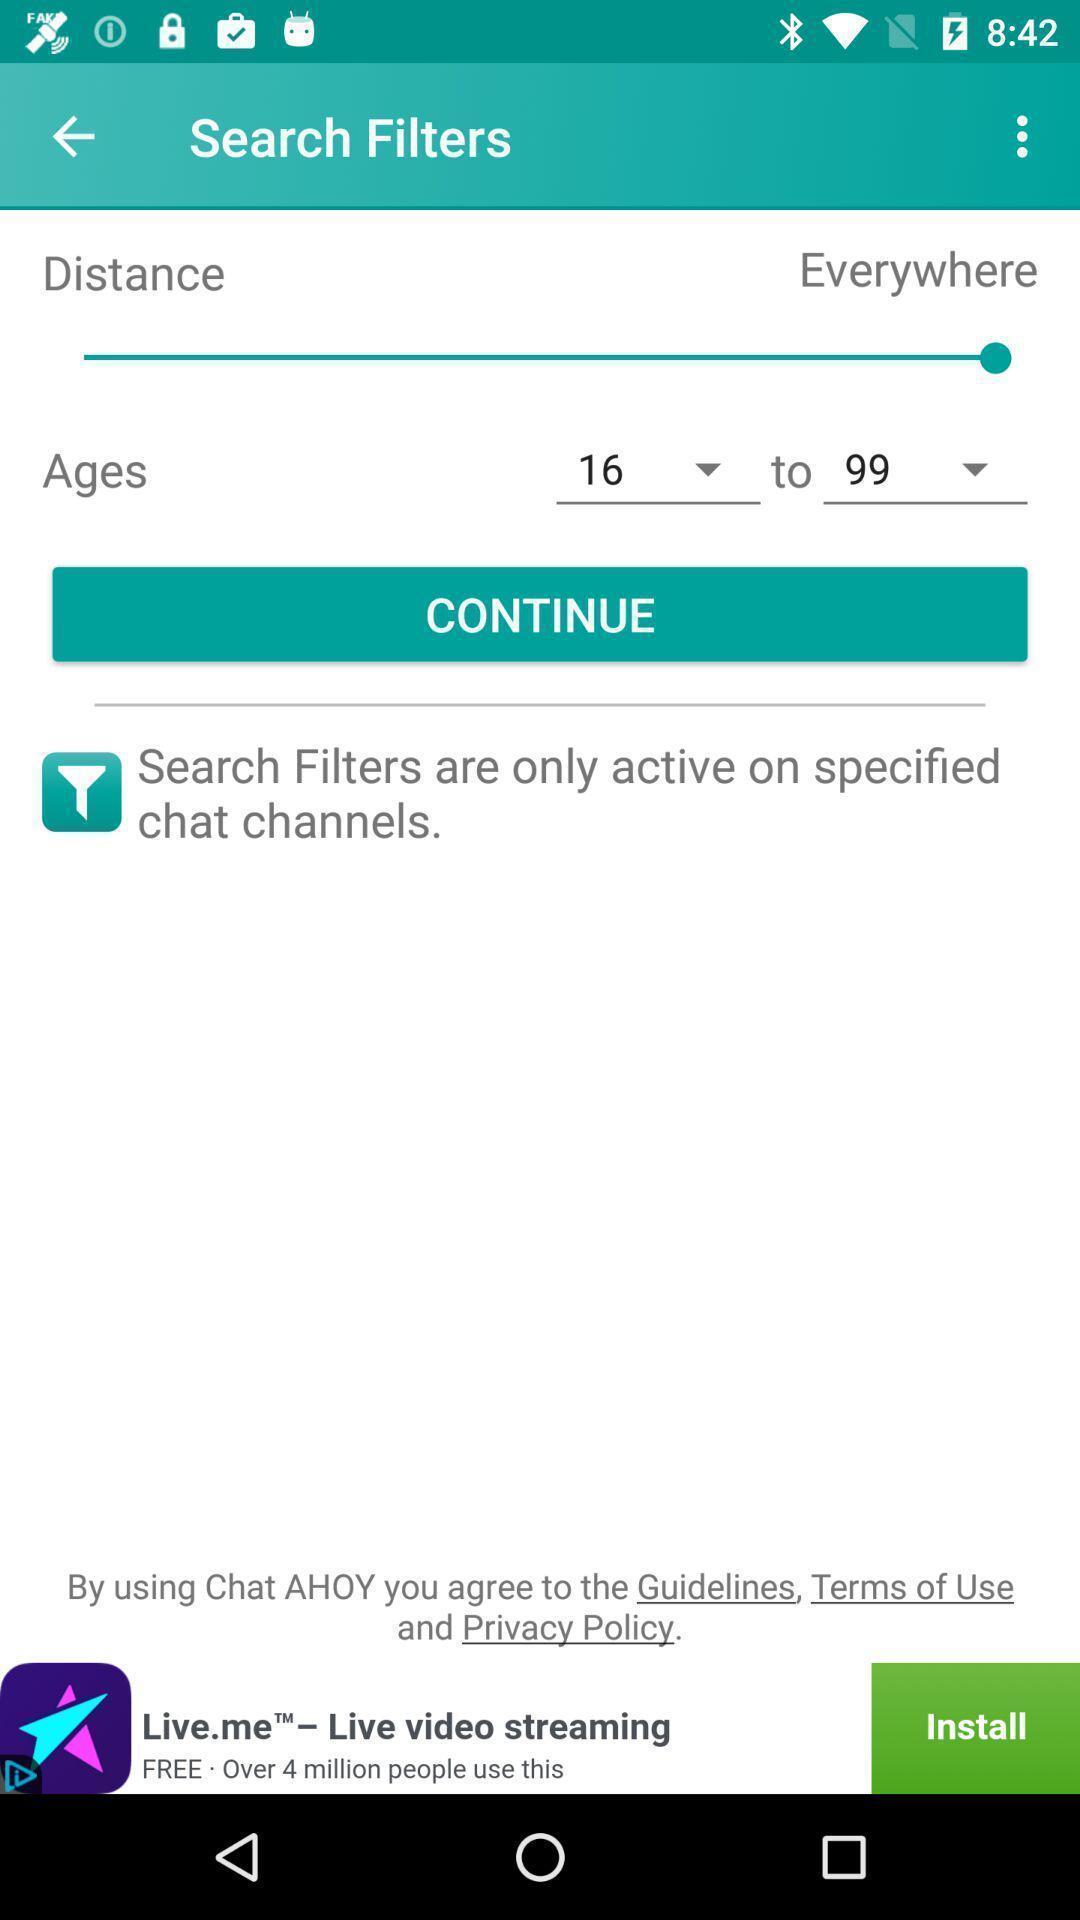Provide a detailed account of this screenshot. Screen shows to search filters. 